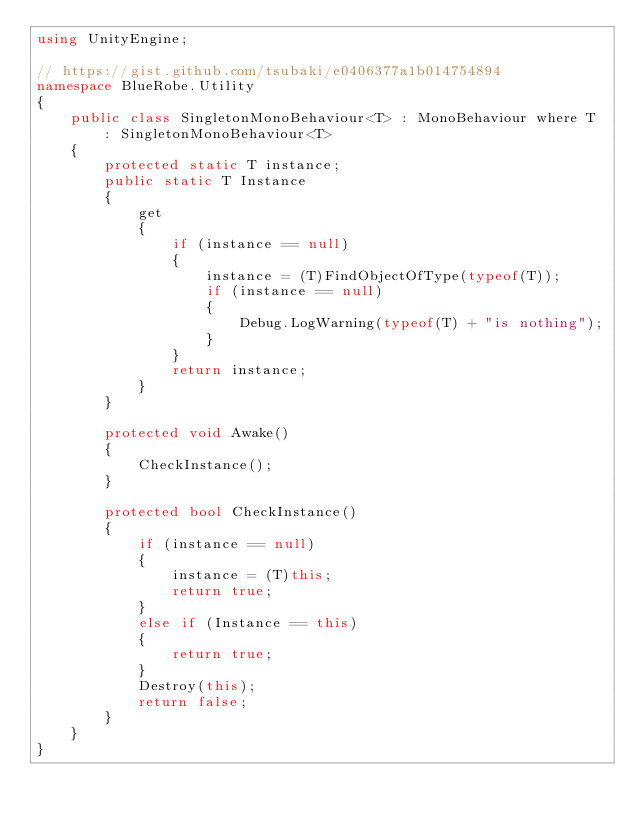Convert code to text. <code><loc_0><loc_0><loc_500><loc_500><_C#_>using UnityEngine;

// https://gist.github.com/tsubaki/e0406377a1b014754894
namespace BlueRobe.Utility
{
    public class SingletonMonoBehaviour<T> : MonoBehaviour where T : SingletonMonoBehaviour<T>
    {
        protected static T instance;
        public static T Instance
        {
            get
            {
                if (instance == null)
                {
                    instance = (T)FindObjectOfType(typeof(T));
                    if (instance == null)
                    {
                        Debug.LogWarning(typeof(T) + "is nothing");
                    }
                }
                return instance;
            }
        }

        protected void Awake()
        {
            CheckInstance();
        }

        protected bool CheckInstance()
        {
            if (instance == null)
            {
                instance = (T)this;
                return true;
            }
            else if (Instance == this)
            {
                return true;
            }
            Destroy(this);
            return false;
        }
    }
}
</code> 